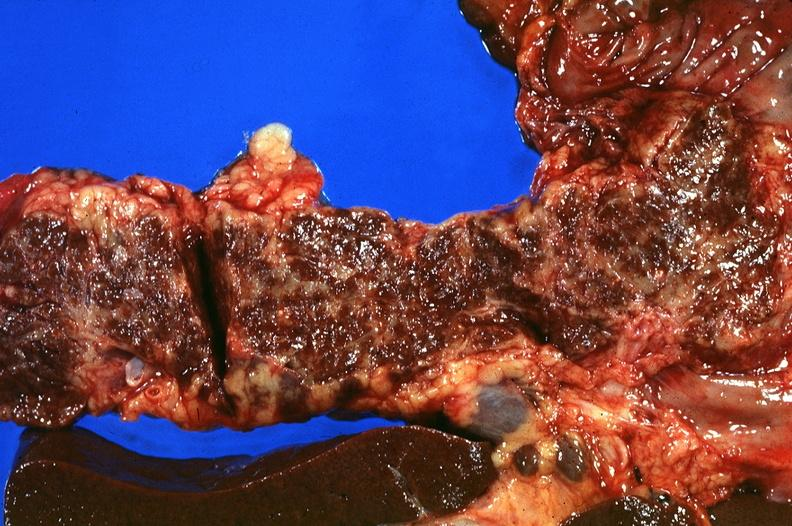what does this image show?
Answer the question using a single word or phrase. Pancreas 